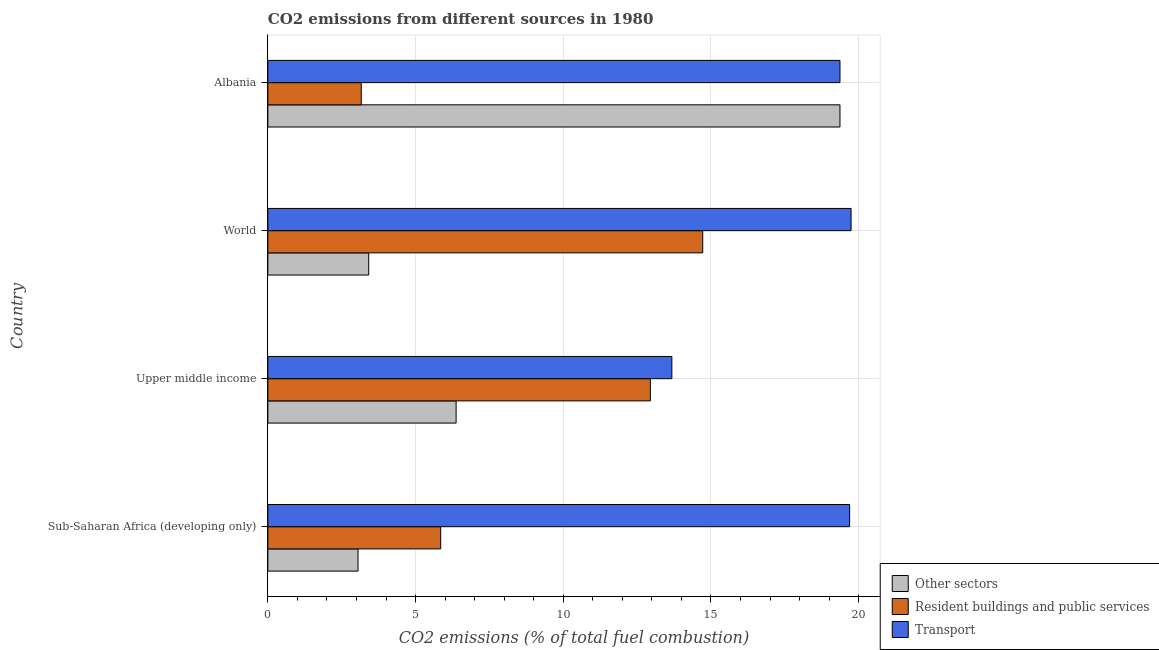Are the number of bars per tick equal to the number of legend labels?
Your answer should be very brief. Yes. How many bars are there on the 2nd tick from the top?
Your response must be concise. 3. How many bars are there on the 4th tick from the bottom?
Keep it short and to the point. 3. What is the label of the 3rd group of bars from the top?
Your answer should be very brief. Upper middle income. What is the percentage of co2 emissions from other sectors in Upper middle income?
Make the answer very short. 6.37. Across all countries, what is the maximum percentage of co2 emissions from other sectors?
Your answer should be very brief. 19.37. Across all countries, what is the minimum percentage of co2 emissions from transport?
Offer a very short reply. 13.68. In which country was the percentage of co2 emissions from transport minimum?
Offer a terse response. Upper middle income. What is the total percentage of co2 emissions from transport in the graph?
Your response must be concise. 72.48. What is the difference between the percentage of co2 emissions from other sectors in Albania and that in World?
Provide a succinct answer. 15.95. What is the difference between the percentage of co2 emissions from resident buildings and public services in World and the percentage of co2 emissions from transport in Albania?
Offer a terse response. -4.65. What is the average percentage of co2 emissions from other sectors per country?
Offer a terse response. 8.05. What is the difference between the percentage of co2 emissions from other sectors and percentage of co2 emissions from transport in Sub-Saharan Africa (developing only)?
Ensure brevity in your answer.  -16.64. What is the ratio of the percentage of co2 emissions from other sectors in Albania to that in Sub-Saharan Africa (developing only)?
Provide a succinct answer. 6.34. Is the percentage of co2 emissions from transport in Albania less than that in Upper middle income?
Your answer should be compact. No. Is the difference between the percentage of co2 emissions from transport in Albania and Upper middle income greater than the difference between the percentage of co2 emissions from resident buildings and public services in Albania and Upper middle income?
Your response must be concise. Yes. What is the difference between the highest and the second highest percentage of co2 emissions from resident buildings and public services?
Your response must be concise. 1.77. What is the difference between the highest and the lowest percentage of co2 emissions from other sectors?
Provide a succinct answer. 16.31. Is the sum of the percentage of co2 emissions from other sectors in Albania and World greater than the maximum percentage of co2 emissions from resident buildings and public services across all countries?
Your answer should be very brief. Yes. What does the 3rd bar from the top in Albania represents?
Ensure brevity in your answer.  Other sectors. What does the 1st bar from the bottom in Upper middle income represents?
Give a very brief answer. Other sectors. How many bars are there?
Offer a very short reply. 12. How many countries are there in the graph?
Your answer should be very brief. 4. Does the graph contain grids?
Offer a very short reply. Yes. Where does the legend appear in the graph?
Make the answer very short. Bottom right. What is the title of the graph?
Keep it short and to the point. CO2 emissions from different sources in 1980. What is the label or title of the X-axis?
Offer a very short reply. CO2 emissions (% of total fuel combustion). What is the label or title of the Y-axis?
Provide a short and direct response. Country. What is the CO2 emissions (% of total fuel combustion) of Other sectors in Sub-Saharan Africa (developing only)?
Your answer should be very brief. 3.05. What is the CO2 emissions (% of total fuel combustion) of Resident buildings and public services in Sub-Saharan Africa (developing only)?
Your answer should be very brief. 5.85. What is the CO2 emissions (% of total fuel combustion) of Transport in Sub-Saharan Africa (developing only)?
Ensure brevity in your answer.  19.69. What is the CO2 emissions (% of total fuel combustion) in Other sectors in Upper middle income?
Keep it short and to the point. 6.37. What is the CO2 emissions (% of total fuel combustion) in Resident buildings and public services in Upper middle income?
Offer a terse response. 12.95. What is the CO2 emissions (% of total fuel combustion) of Transport in Upper middle income?
Offer a very short reply. 13.68. What is the CO2 emissions (% of total fuel combustion) of Other sectors in World?
Your answer should be very brief. 3.41. What is the CO2 emissions (% of total fuel combustion) in Resident buildings and public services in World?
Offer a terse response. 14.72. What is the CO2 emissions (% of total fuel combustion) of Transport in World?
Offer a very short reply. 19.74. What is the CO2 emissions (% of total fuel combustion) of Other sectors in Albania?
Your answer should be compact. 19.37. What is the CO2 emissions (% of total fuel combustion) of Resident buildings and public services in Albania?
Your answer should be compact. 3.16. What is the CO2 emissions (% of total fuel combustion) in Transport in Albania?
Provide a succinct answer. 19.37. Across all countries, what is the maximum CO2 emissions (% of total fuel combustion) in Other sectors?
Offer a terse response. 19.37. Across all countries, what is the maximum CO2 emissions (% of total fuel combustion) in Resident buildings and public services?
Offer a very short reply. 14.72. Across all countries, what is the maximum CO2 emissions (% of total fuel combustion) in Transport?
Provide a short and direct response. 19.74. Across all countries, what is the minimum CO2 emissions (% of total fuel combustion) of Other sectors?
Your response must be concise. 3.05. Across all countries, what is the minimum CO2 emissions (% of total fuel combustion) in Resident buildings and public services?
Provide a short and direct response. 3.16. Across all countries, what is the minimum CO2 emissions (% of total fuel combustion) of Transport?
Offer a very short reply. 13.68. What is the total CO2 emissions (% of total fuel combustion) in Other sectors in the graph?
Make the answer very short. 32.21. What is the total CO2 emissions (% of total fuel combustion) in Resident buildings and public services in the graph?
Provide a succinct answer. 36.68. What is the total CO2 emissions (% of total fuel combustion) of Transport in the graph?
Keep it short and to the point. 72.48. What is the difference between the CO2 emissions (% of total fuel combustion) of Other sectors in Sub-Saharan Africa (developing only) and that in Upper middle income?
Keep it short and to the point. -3.32. What is the difference between the CO2 emissions (% of total fuel combustion) in Resident buildings and public services in Sub-Saharan Africa (developing only) and that in Upper middle income?
Provide a succinct answer. -7.1. What is the difference between the CO2 emissions (% of total fuel combustion) in Transport in Sub-Saharan Africa (developing only) and that in Upper middle income?
Offer a terse response. 6.02. What is the difference between the CO2 emissions (% of total fuel combustion) of Other sectors in Sub-Saharan Africa (developing only) and that in World?
Provide a succinct answer. -0.36. What is the difference between the CO2 emissions (% of total fuel combustion) of Resident buildings and public services in Sub-Saharan Africa (developing only) and that in World?
Keep it short and to the point. -8.87. What is the difference between the CO2 emissions (% of total fuel combustion) of Transport in Sub-Saharan Africa (developing only) and that in World?
Your answer should be very brief. -0.05. What is the difference between the CO2 emissions (% of total fuel combustion) of Other sectors in Sub-Saharan Africa (developing only) and that in Albania?
Make the answer very short. -16.31. What is the difference between the CO2 emissions (% of total fuel combustion) of Resident buildings and public services in Sub-Saharan Africa (developing only) and that in Albania?
Your response must be concise. 2.69. What is the difference between the CO2 emissions (% of total fuel combustion) of Transport in Sub-Saharan Africa (developing only) and that in Albania?
Your answer should be very brief. 0.33. What is the difference between the CO2 emissions (% of total fuel combustion) in Other sectors in Upper middle income and that in World?
Provide a succinct answer. 2.96. What is the difference between the CO2 emissions (% of total fuel combustion) in Resident buildings and public services in Upper middle income and that in World?
Provide a short and direct response. -1.77. What is the difference between the CO2 emissions (% of total fuel combustion) in Transport in Upper middle income and that in World?
Provide a succinct answer. -6.07. What is the difference between the CO2 emissions (% of total fuel combustion) in Other sectors in Upper middle income and that in Albania?
Your answer should be compact. -12.99. What is the difference between the CO2 emissions (% of total fuel combustion) in Resident buildings and public services in Upper middle income and that in Albania?
Make the answer very short. 9.79. What is the difference between the CO2 emissions (% of total fuel combustion) in Transport in Upper middle income and that in Albania?
Your answer should be compact. -5.69. What is the difference between the CO2 emissions (% of total fuel combustion) of Other sectors in World and that in Albania?
Your answer should be very brief. -15.95. What is the difference between the CO2 emissions (% of total fuel combustion) of Resident buildings and public services in World and that in Albania?
Your response must be concise. 11.56. What is the difference between the CO2 emissions (% of total fuel combustion) of Transport in World and that in Albania?
Make the answer very short. 0.38. What is the difference between the CO2 emissions (% of total fuel combustion) of Other sectors in Sub-Saharan Africa (developing only) and the CO2 emissions (% of total fuel combustion) of Resident buildings and public services in Upper middle income?
Offer a terse response. -9.9. What is the difference between the CO2 emissions (% of total fuel combustion) in Other sectors in Sub-Saharan Africa (developing only) and the CO2 emissions (% of total fuel combustion) in Transport in Upper middle income?
Your answer should be very brief. -10.62. What is the difference between the CO2 emissions (% of total fuel combustion) in Resident buildings and public services in Sub-Saharan Africa (developing only) and the CO2 emissions (% of total fuel combustion) in Transport in Upper middle income?
Your answer should be very brief. -7.83. What is the difference between the CO2 emissions (% of total fuel combustion) in Other sectors in Sub-Saharan Africa (developing only) and the CO2 emissions (% of total fuel combustion) in Resident buildings and public services in World?
Keep it short and to the point. -11.67. What is the difference between the CO2 emissions (% of total fuel combustion) of Other sectors in Sub-Saharan Africa (developing only) and the CO2 emissions (% of total fuel combustion) of Transport in World?
Give a very brief answer. -16.69. What is the difference between the CO2 emissions (% of total fuel combustion) of Resident buildings and public services in Sub-Saharan Africa (developing only) and the CO2 emissions (% of total fuel combustion) of Transport in World?
Your answer should be very brief. -13.89. What is the difference between the CO2 emissions (% of total fuel combustion) in Other sectors in Sub-Saharan Africa (developing only) and the CO2 emissions (% of total fuel combustion) in Resident buildings and public services in Albania?
Your response must be concise. -0.11. What is the difference between the CO2 emissions (% of total fuel combustion) of Other sectors in Sub-Saharan Africa (developing only) and the CO2 emissions (% of total fuel combustion) of Transport in Albania?
Ensure brevity in your answer.  -16.31. What is the difference between the CO2 emissions (% of total fuel combustion) of Resident buildings and public services in Sub-Saharan Africa (developing only) and the CO2 emissions (% of total fuel combustion) of Transport in Albania?
Provide a short and direct response. -13.52. What is the difference between the CO2 emissions (% of total fuel combustion) of Other sectors in Upper middle income and the CO2 emissions (% of total fuel combustion) of Resident buildings and public services in World?
Your answer should be very brief. -8.35. What is the difference between the CO2 emissions (% of total fuel combustion) of Other sectors in Upper middle income and the CO2 emissions (% of total fuel combustion) of Transport in World?
Keep it short and to the point. -13.37. What is the difference between the CO2 emissions (% of total fuel combustion) in Resident buildings and public services in Upper middle income and the CO2 emissions (% of total fuel combustion) in Transport in World?
Provide a short and direct response. -6.79. What is the difference between the CO2 emissions (% of total fuel combustion) of Other sectors in Upper middle income and the CO2 emissions (% of total fuel combustion) of Resident buildings and public services in Albania?
Keep it short and to the point. 3.21. What is the difference between the CO2 emissions (% of total fuel combustion) in Other sectors in Upper middle income and the CO2 emissions (% of total fuel combustion) in Transport in Albania?
Offer a very short reply. -12.99. What is the difference between the CO2 emissions (% of total fuel combustion) in Resident buildings and public services in Upper middle income and the CO2 emissions (% of total fuel combustion) in Transport in Albania?
Give a very brief answer. -6.42. What is the difference between the CO2 emissions (% of total fuel combustion) in Other sectors in World and the CO2 emissions (% of total fuel combustion) in Resident buildings and public services in Albania?
Provide a short and direct response. 0.25. What is the difference between the CO2 emissions (% of total fuel combustion) in Other sectors in World and the CO2 emissions (% of total fuel combustion) in Transport in Albania?
Offer a very short reply. -15.95. What is the difference between the CO2 emissions (% of total fuel combustion) of Resident buildings and public services in World and the CO2 emissions (% of total fuel combustion) of Transport in Albania?
Offer a terse response. -4.65. What is the average CO2 emissions (% of total fuel combustion) of Other sectors per country?
Ensure brevity in your answer.  8.05. What is the average CO2 emissions (% of total fuel combustion) of Resident buildings and public services per country?
Make the answer very short. 9.17. What is the average CO2 emissions (% of total fuel combustion) in Transport per country?
Your answer should be compact. 18.12. What is the difference between the CO2 emissions (% of total fuel combustion) in Other sectors and CO2 emissions (% of total fuel combustion) in Resident buildings and public services in Sub-Saharan Africa (developing only)?
Provide a succinct answer. -2.8. What is the difference between the CO2 emissions (% of total fuel combustion) in Other sectors and CO2 emissions (% of total fuel combustion) in Transport in Sub-Saharan Africa (developing only)?
Your response must be concise. -16.64. What is the difference between the CO2 emissions (% of total fuel combustion) in Resident buildings and public services and CO2 emissions (% of total fuel combustion) in Transport in Sub-Saharan Africa (developing only)?
Offer a very short reply. -13.84. What is the difference between the CO2 emissions (% of total fuel combustion) of Other sectors and CO2 emissions (% of total fuel combustion) of Resident buildings and public services in Upper middle income?
Provide a short and direct response. -6.58. What is the difference between the CO2 emissions (% of total fuel combustion) of Other sectors and CO2 emissions (% of total fuel combustion) of Transport in Upper middle income?
Your response must be concise. -7.3. What is the difference between the CO2 emissions (% of total fuel combustion) of Resident buildings and public services and CO2 emissions (% of total fuel combustion) of Transport in Upper middle income?
Provide a short and direct response. -0.73. What is the difference between the CO2 emissions (% of total fuel combustion) of Other sectors and CO2 emissions (% of total fuel combustion) of Resident buildings and public services in World?
Offer a very short reply. -11.31. What is the difference between the CO2 emissions (% of total fuel combustion) of Other sectors and CO2 emissions (% of total fuel combustion) of Transport in World?
Ensure brevity in your answer.  -16.33. What is the difference between the CO2 emissions (% of total fuel combustion) in Resident buildings and public services and CO2 emissions (% of total fuel combustion) in Transport in World?
Give a very brief answer. -5.02. What is the difference between the CO2 emissions (% of total fuel combustion) of Other sectors and CO2 emissions (% of total fuel combustion) of Resident buildings and public services in Albania?
Offer a terse response. 16.21. What is the difference between the CO2 emissions (% of total fuel combustion) in Other sectors and CO2 emissions (% of total fuel combustion) in Transport in Albania?
Provide a succinct answer. 0. What is the difference between the CO2 emissions (% of total fuel combustion) in Resident buildings and public services and CO2 emissions (% of total fuel combustion) in Transport in Albania?
Provide a succinct answer. -16.21. What is the ratio of the CO2 emissions (% of total fuel combustion) of Other sectors in Sub-Saharan Africa (developing only) to that in Upper middle income?
Provide a short and direct response. 0.48. What is the ratio of the CO2 emissions (% of total fuel combustion) in Resident buildings and public services in Sub-Saharan Africa (developing only) to that in Upper middle income?
Make the answer very short. 0.45. What is the ratio of the CO2 emissions (% of total fuel combustion) in Transport in Sub-Saharan Africa (developing only) to that in Upper middle income?
Give a very brief answer. 1.44. What is the ratio of the CO2 emissions (% of total fuel combustion) of Other sectors in Sub-Saharan Africa (developing only) to that in World?
Keep it short and to the point. 0.89. What is the ratio of the CO2 emissions (% of total fuel combustion) of Resident buildings and public services in Sub-Saharan Africa (developing only) to that in World?
Offer a very short reply. 0.4. What is the ratio of the CO2 emissions (% of total fuel combustion) in Transport in Sub-Saharan Africa (developing only) to that in World?
Keep it short and to the point. 1. What is the ratio of the CO2 emissions (% of total fuel combustion) in Other sectors in Sub-Saharan Africa (developing only) to that in Albania?
Make the answer very short. 0.16. What is the ratio of the CO2 emissions (% of total fuel combustion) in Resident buildings and public services in Sub-Saharan Africa (developing only) to that in Albania?
Keep it short and to the point. 1.85. What is the ratio of the CO2 emissions (% of total fuel combustion) in Transport in Sub-Saharan Africa (developing only) to that in Albania?
Your response must be concise. 1.02. What is the ratio of the CO2 emissions (% of total fuel combustion) in Other sectors in Upper middle income to that in World?
Give a very brief answer. 1.87. What is the ratio of the CO2 emissions (% of total fuel combustion) of Resident buildings and public services in Upper middle income to that in World?
Provide a succinct answer. 0.88. What is the ratio of the CO2 emissions (% of total fuel combustion) in Transport in Upper middle income to that in World?
Give a very brief answer. 0.69. What is the ratio of the CO2 emissions (% of total fuel combustion) in Other sectors in Upper middle income to that in Albania?
Offer a terse response. 0.33. What is the ratio of the CO2 emissions (% of total fuel combustion) of Resident buildings and public services in Upper middle income to that in Albania?
Give a very brief answer. 4.1. What is the ratio of the CO2 emissions (% of total fuel combustion) of Transport in Upper middle income to that in Albania?
Provide a short and direct response. 0.71. What is the ratio of the CO2 emissions (% of total fuel combustion) of Other sectors in World to that in Albania?
Offer a terse response. 0.18. What is the ratio of the CO2 emissions (% of total fuel combustion) of Resident buildings and public services in World to that in Albania?
Provide a succinct answer. 4.66. What is the ratio of the CO2 emissions (% of total fuel combustion) of Transport in World to that in Albania?
Offer a very short reply. 1.02. What is the difference between the highest and the second highest CO2 emissions (% of total fuel combustion) in Other sectors?
Your response must be concise. 12.99. What is the difference between the highest and the second highest CO2 emissions (% of total fuel combustion) of Resident buildings and public services?
Keep it short and to the point. 1.77. What is the difference between the highest and the second highest CO2 emissions (% of total fuel combustion) of Transport?
Provide a short and direct response. 0.05. What is the difference between the highest and the lowest CO2 emissions (% of total fuel combustion) in Other sectors?
Offer a very short reply. 16.31. What is the difference between the highest and the lowest CO2 emissions (% of total fuel combustion) of Resident buildings and public services?
Offer a terse response. 11.56. What is the difference between the highest and the lowest CO2 emissions (% of total fuel combustion) of Transport?
Keep it short and to the point. 6.07. 